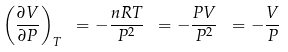<formula> <loc_0><loc_0><loc_500><loc_500>\left ( { \frac { \partial V } { \partial P } } \right ) _ { T } \ = - { \frac { n R T } { P ^ { 2 } } } \ = - { \frac { P V } { P ^ { 2 } } } \ = - { \frac { V } { P } }</formula> 